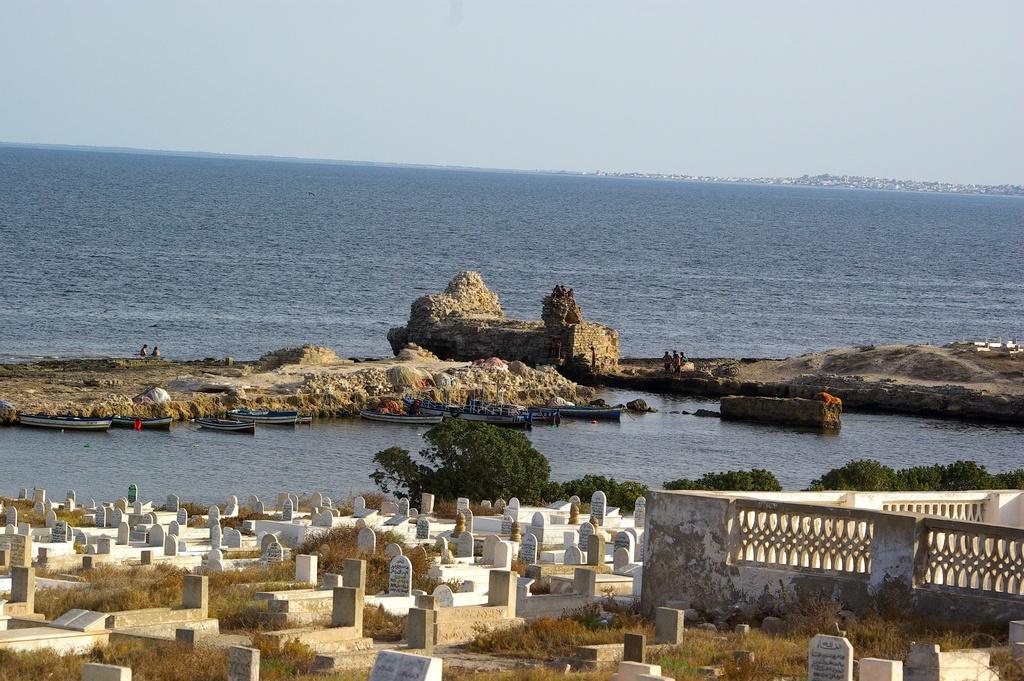In one or two sentences, can you explain what this image depicts? In this image we can see there is a graveyard, beside that there is a wall and trees, in front of that there are few boats on the river and there are rock structures and few people are standing on it. In the background there is the sky. 